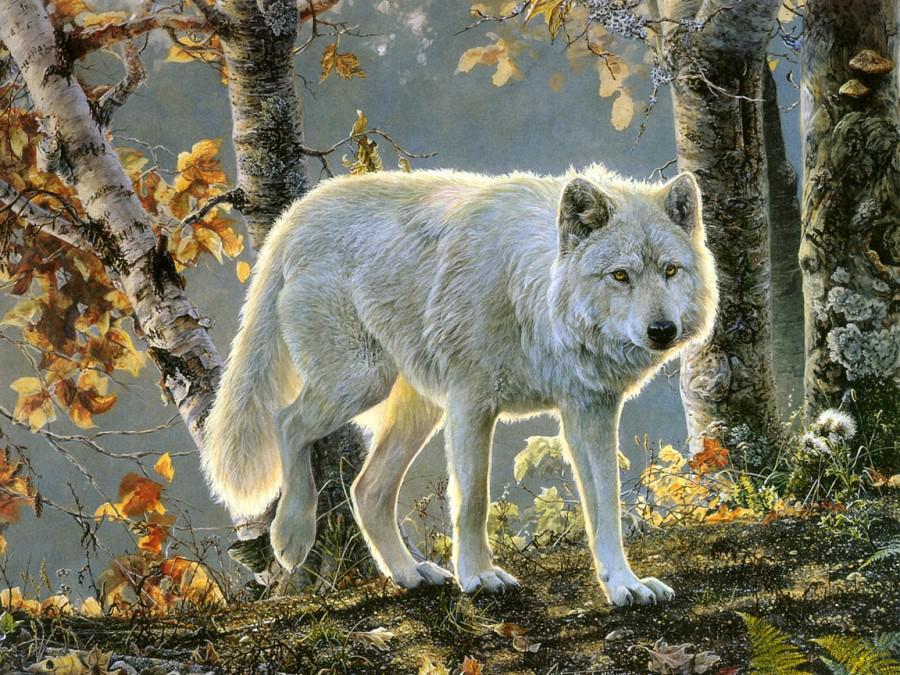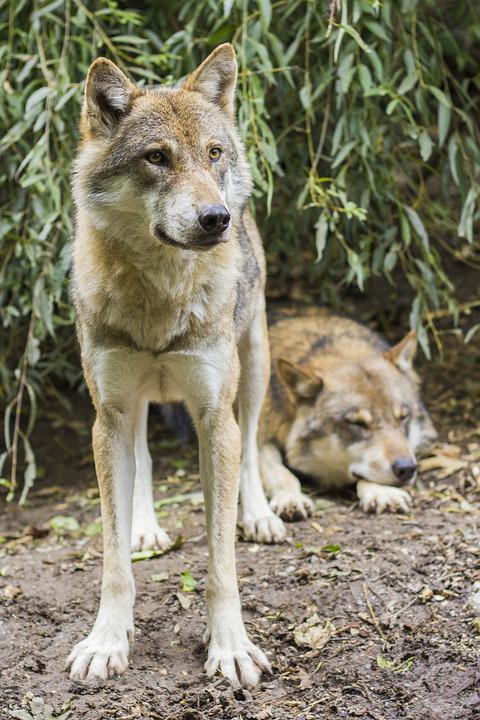The first image is the image on the left, the second image is the image on the right. Assess this claim about the two images: "An image shows only one wolf, standing with its head and body angled rightward, and leaves visible behind it.". Correct or not? Answer yes or no. Yes. The first image is the image on the left, the second image is the image on the right. Evaluate the accuracy of this statement regarding the images: "The wild dog in the image on the left side is lying down on the ground.". Is it true? Answer yes or no. No. 